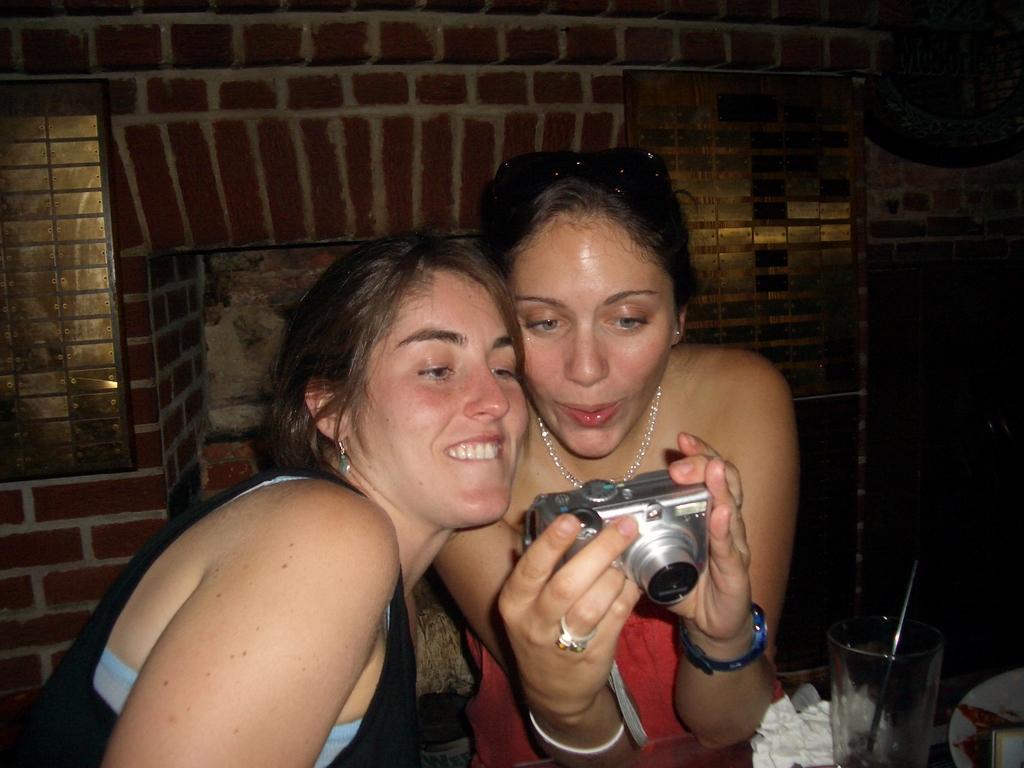In one or two sentences, can you explain what this image depicts? Here we can see a couple of women who are watching in their camera and there is a glass in front of them 